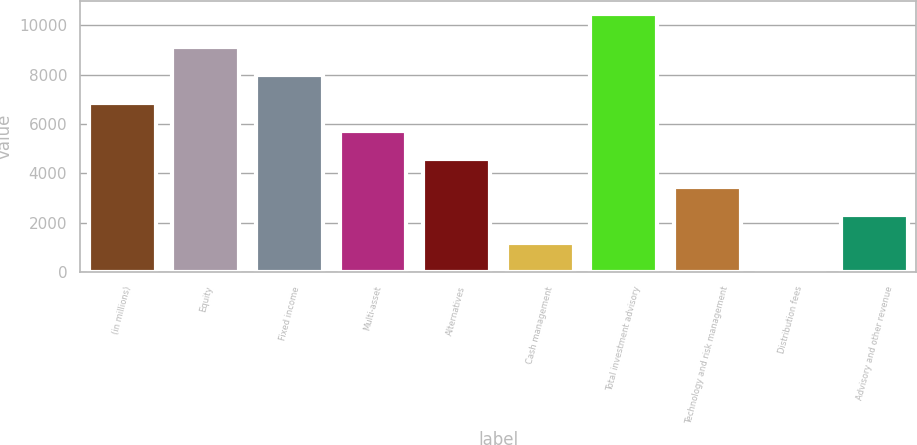Convert chart to OTSL. <chart><loc_0><loc_0><loc_500><loc_500><bar_chart><fcel>(in millions)<fcel>Equity<fcel>Fixed income<fcel>Multi-asset<fcel>Alternatives<fcel>Cash management<fcel>Total investment advisory<fcel>Technology and risk management<fcel>Distribution fees<fcel>Advisory and other revenue<nl><fcel>6862.6<fcel>9131.8<fcel>7997.2<fcel>5728<fcel>4593.4<fcel>1189.6<fcel>10461<fcel>3458.8<fcel>55<fcel>2324.2<nl></chart> 